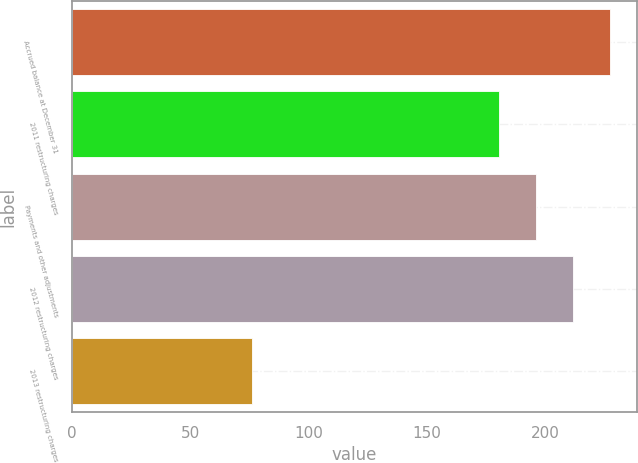<chart> <loc_0><loc_0><loc_500><loc_500><bar_chart><fcel>Accrued balance at December 31<fcel>2011 restructuring charges<fcel>Payments and other adjustments<fcel>2012 restructuring charges<fcel>2013 restructuring charges<nl><fcel>227.5<fcel>180.4<fcel>196.1<fcel>211.8<fcel>76<nl></chart> 